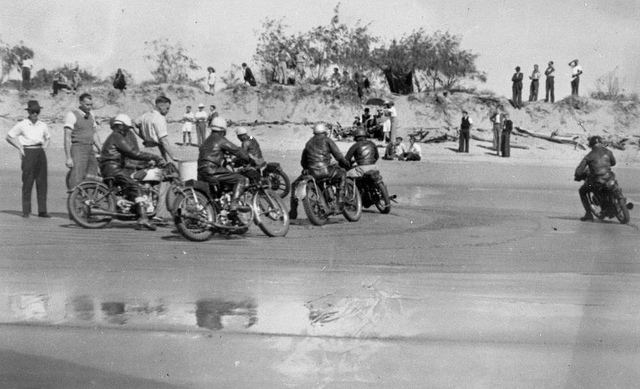Describe the type of motorcycles in the image. The motorcycles in the image appear to be vintage models, likely from the early to mid-20th century. These bikes have a classic design with large, exposed engines, spoked wheels, and low, elongated bodies. The riders are positioned in a way typical of old racing motorcycles, leaning forward over the handlebars, suggesting they are built for speed and agility rather than comfort. What can you infer about the time period and location from the image? From the style of the motorcycles and the clothing of the participants and spectators, it can be inferred that the image is from the early to mid-20th century, likely between the 1930s and 1950s. The location appears to be a beach, with the motorcycles racing on the hard-packed sand. The presence of dunes and some sparse vegetation in the background suggests that this could be a coastal area, perhaps in the United States or Europe, where beach racing was popular during that era. 